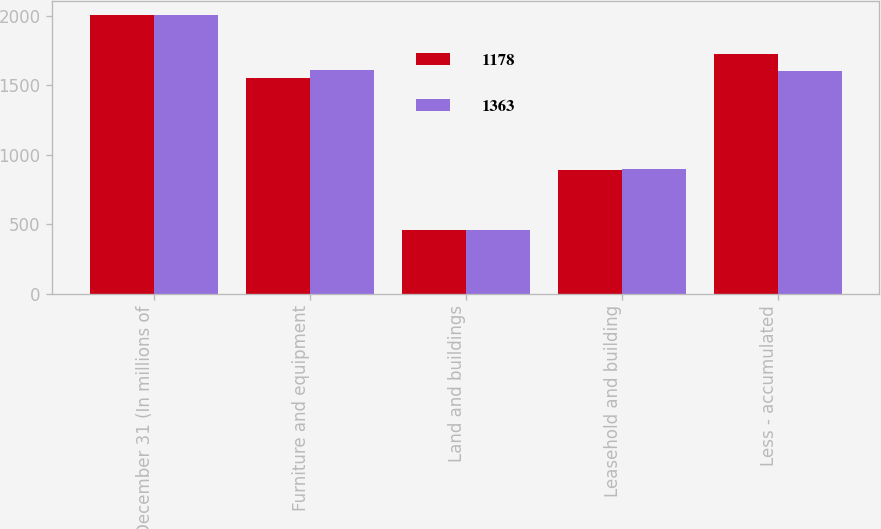<chart> <loc_0><loc_0><loc_500><loc_500><stacked_bar_chart><ecel><fcel>December 31 (In millions of<fcel>Furniture and equipment<fcel>Land and buildings<fcel>Leasehold and building<fcel>Less - accumulated<nl><fcel>1178<fcel>2005<fcel>1557<fcel>457<fcel>888<fcel>1724<nl><fcel>1363<fcel>2004<fcel>1612<fcel>457<fcel>897<fcel>1603<nl></chart> 